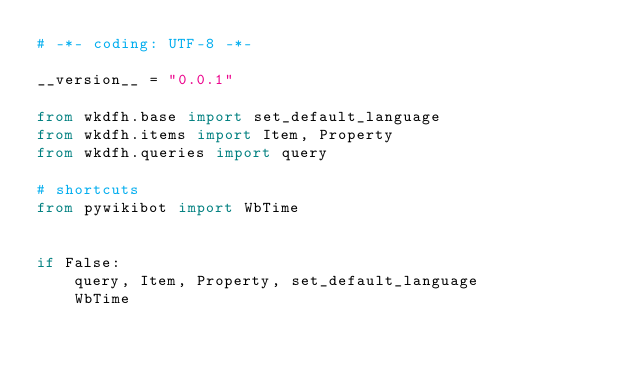Convert code to text. <code><loc_0><loc_0><loc_500><loc_500><_Python_># -*- coding: UTF-8 -*-

__version__ = "0.0.1"

from wkdfh.base import set_default_language
from wkdfh.items import Item, Property
from wkdfh.queries import query

# shortcuts
from pywikibot import WbTime


if False:
    query, Item, Property, set_default_language
    WbTime
</code> 